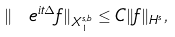<formula> <loc_0><loc_0><loc_500><loc_500>\| \ e ^ { i t \Delta } f \| _ { X ^ { s , b } _ { 1 } } \leq C \| f \| _ { H ^ { s } } ,</formula> 